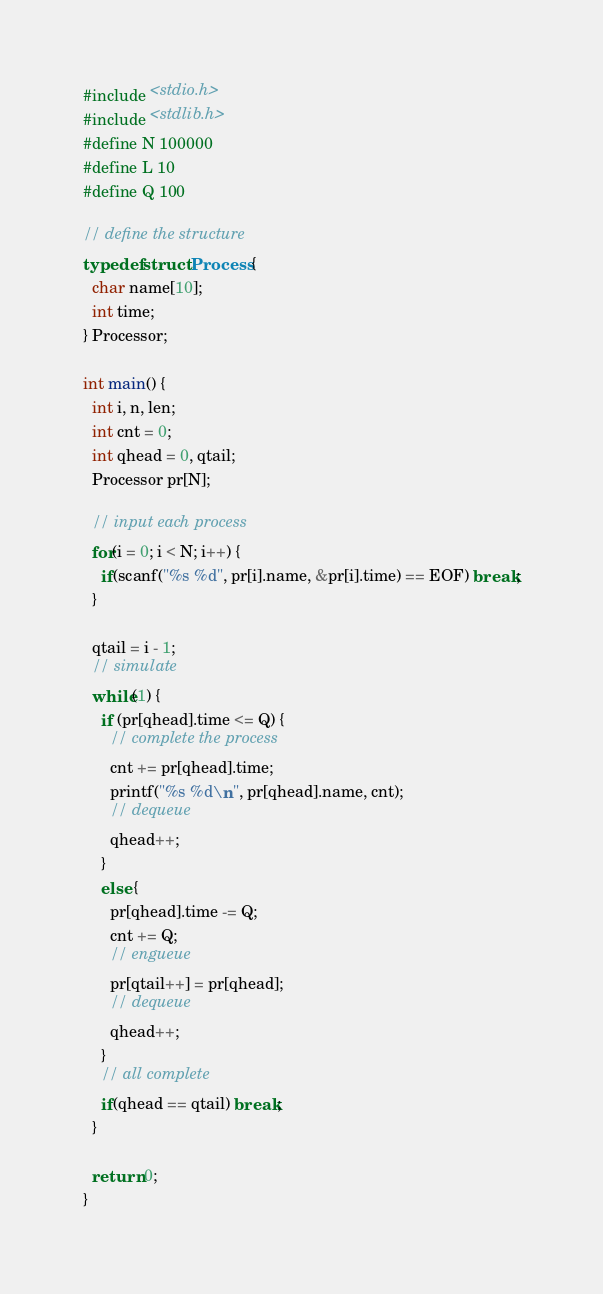<code> <loc_0><loc_0><loc_500><loc_500><_C_>#include <stdio.h>
#include <stdlib.h>
#define N 100000
#define L 10
#define Q 100

// define the structure
typedef struct Process {
  char name[10];
  int time;
} Processor;

int main() {
  int i, n, len;
  int cnt = 0;
  int qhead = 0, qtail;
  Processor pr[N];

  // input each process
  for(i = 0; i < N; i++) {
    if(scanf("%s %d", pr[i].name, &pr[i].time) == EOF) break;
  }

  qtail = i - 1;
  // simulate
  while(1) {
    if (pr[qhead].time <= Q) {
      // complete the process
      cnt += pr[qhead].time;
      printf("%s %d\n", pr[qhead].name, cnt);
      // dequeue
      qhead++;
    }
    else {
      pr[qhead].time -= Q;
      cnt += Q;   
      // engueue
      pr[qtail++] = pr[qhead];
      // dequeue
      qhead++;
    }
    // all complete
    if(qhead == qtail) break;
  }
  
  return 0;
}

</code> 